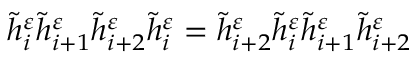Convert formula to latex. <formula><loc_0><loc_0><loc_500><loc_500>\widetilde { h } _ { i } ^ { \varepsilon } \widetilde { h } _ { i + 1 } ^ { \varepsilon } \widetilde { h } _ { i + 2 } ^ { \varepsilon } \widetilde { h } _ { i } ^ { \varepsilon } = \widetilde { h } _ { i + 2 } ^ { \varepsilon } \widetilde { h } _ { i } ^ { \varepsilon } \widetilde { h } _ { i + 1 } ^ { \varepsilon } \widetilde { h } _ { i + 2 } ^ { \varepsilon }</formula> 